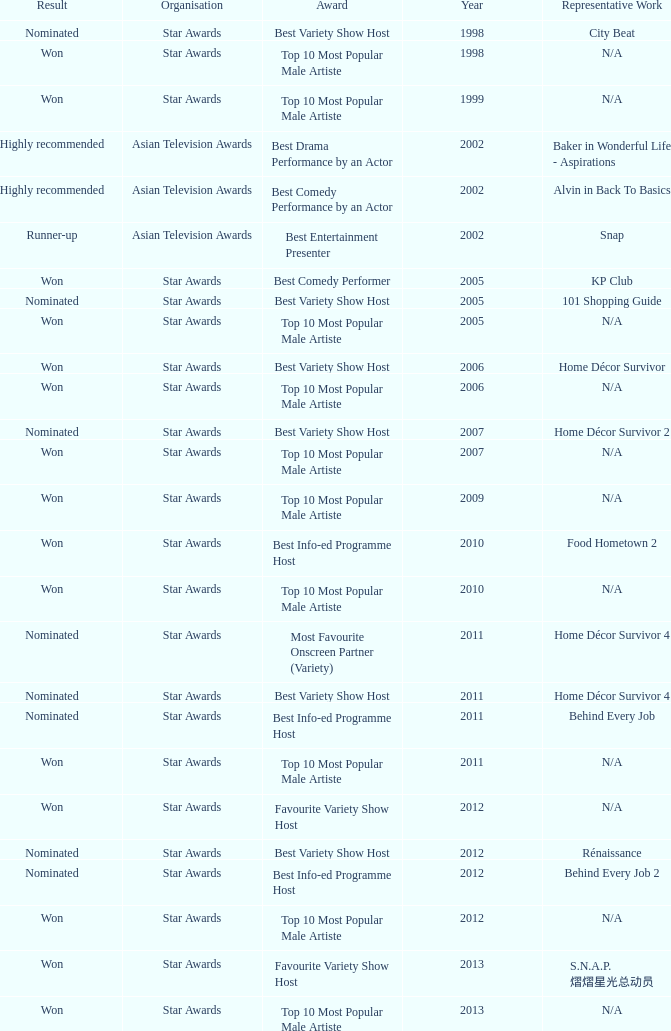What is the award for 1998 with Representative Work of city beat? Best Variety Show Host. 